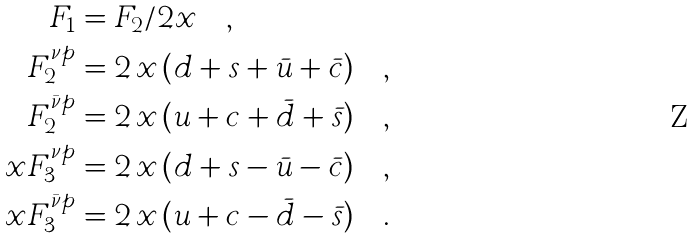<formula> <loc_0><loc_0><loc_500><loc_500>F _ { 1 } & = F _ { 2 } / 2 x \quad , \\ F _ { 2 } ^ { \nu p } & = 2 \, x \, ( d + s + \bar { u } + \bar { c } ) \quad , \\ F _ { 2 } ^ { \bar { \nu } p } & = 2 \, x \, ( u + c + \bar { d } + \bar { s } ) \quad , \\ x F _ { 3 } ^ { \nu p } & = 2 \, x \, ( d + s - \bar { u } - \bar { c } ) \quad , \\ x F _ { 3 } ^ { \bar { \nu } p } & = 2 \, x \, ( u + c - \bar { d } - \bar { s } ) \quad .</formula> 